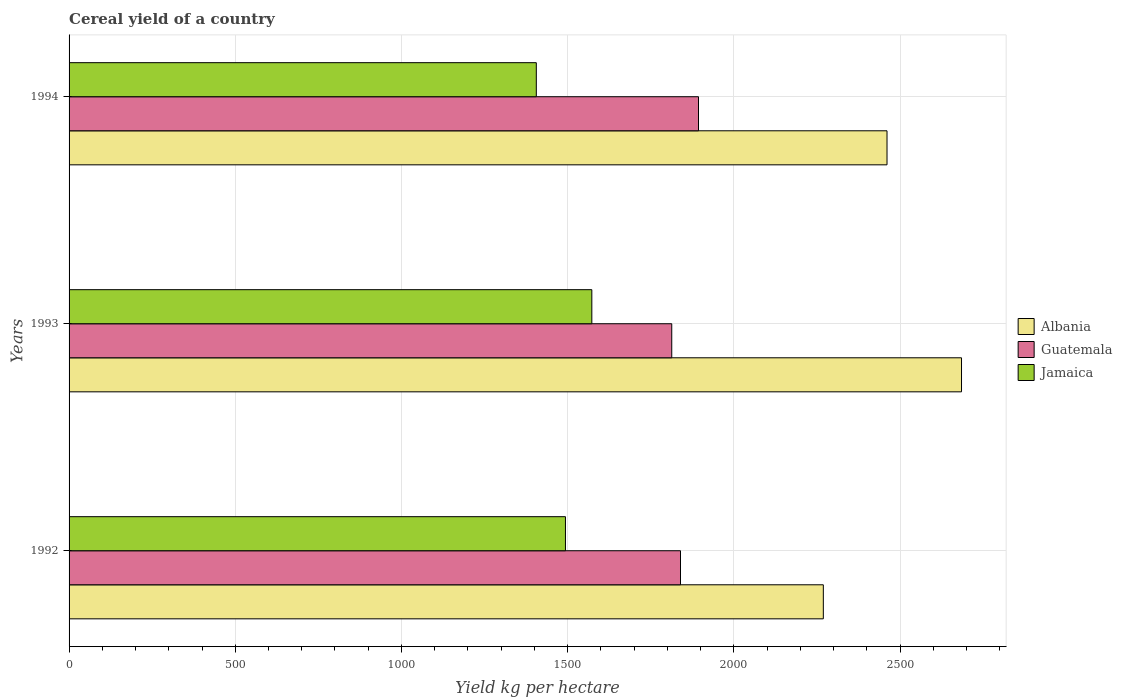Are the number of bars on each tick of the Y-axis equal?
Ensure brevity in your answer.  Yes. How many bars are there on the 2nd tick from the top?
Keep it short and to the point. 3. How many bars are there on the 2nd tick from the bottom?
Your answer should be very brief. 3. In how many cases, is the number of bars for a given year not equal to the number of legend labels?
Your answer should be very brief. 0. What is the total cereal yield in Guatemala in 1994?
Your answer should be compact. 1893.76. Across all years, what is the maximum total cereal yield in Albania?
Provide a succinct answer. 2685.05. Across all years, what is the minimum total cereal yield in Albania?
Offer a terse response. 2269.28. What is the total total cereal yield in Albania in the graph?
Provide a succinct answer. 7415.24. What is the difference between the total cereal yield in Albania in 1992 and that in 1994?
Provide a short and direct response. -191.63. What is the difference between the total cereal yield in Guatemala in 1992 and the total cereal yield in Albania in 1994?
Your answer should be compact. -621.31. What is the average total cereal yield in Jamaica per year?
Provide a succinct answer. 1490.69. In the year 1992, what is the difference between the total cereal yield in Jamaica and total cereal yield in Albania?
Make the answer very short. -775.83. In how many years, is the total cereal yield in Jamaica greater than 2300 kg per hectare?
Ensure brevity in your answer.  0. What is the ratio of the total cereal yield in Guatemala in 1992 to that in 1994?
Ensure brevity in your answer.  0.97. Is the total cereal yield in Albania in 1992 less than that in 1994?
Your answer should be compact. Yes. Is the difference between the total cereal yield in Jamaica in 1993 and 1994 greater than the difference between the total cereal yield in Albania in 1993 and 1994?
Offer a terse response. No. What is the difference between the highest and the second highest total cereal yield in Albania?
Provide a succinct answer. 224.14. What is the difference between the highest and the lowest total cereal yield in Guatemala?
Your response must be concise. 80.48. Is the sum of the total cereal yield in Albania in 1993 and 1994 greater than the maximum total cereal yield in Jamaica across all years?
Make the answer very short. Yes. What does the 1st bar from the top in 1992 represents?
Offer a terse response. Jamaica. What does the 1st bar from the bottom in 1993 represents?
Keep it short and to the point. Albania. Are all the bars in the graph horizontal?
Offer a terse response. Yes. What is the difference between two consecutive major ticks on the X-axis?
Give a very brief answer. 500. Are the values on the major ticks of X-axis written in scientific E-notation?
Provide a short and direct response. No. Does the graph contain any zero values?
Give a very brief answer. No. Where does the legend appear in the graph?
Your response must be concise. Center right. What is the title of the graph?
Make the answer very short. Cereal yield of a country. Does "Iraq" appear as one of the legend labels in the graph?
Give a very brief answer. No. What is the label or title of the X-axis?
Offer a very short reply. Yield kg per hectare. What is the Yield kg per hectare in Albania in 1992?
Offer a terse response. 2269.28. What is the Yield kg per hectare in Guatemala in 1992?
Provide a succinct answer. 1839.6. What is the Yield kg per hectare in Jamaica in 1992?
Your answer should be compact. 1493.45. What is the Yield kg per hectare of Albania in 1993?
Your response must be concise. 2685.05. What is the Yield kg per hectare of Guatemala in 1993?
Offer a terse response. 1813.28. What is the Yield kg per hectare in Jamaica in 1993?
Provide a short and direct response. 1572.82. What is the Yield kg per hectare in Albania in 1994?
Offer a terse response. 2460.91. What is the Yield kg per hectare of Guatemala in 1994?
Ensure brevity in your answer.  1893.76. What is the Yield kg per hectare of Jamaica in 1994?
Your answer should be very brief. 1405.79. Across all years, what is the maximum Yield kg per hectare of Albania?
Keep it short and to the point. 2685.05. Across all years, what is the maximum Yield kg per hectare in Guatemala?
Ensure brevity in your answer.  1893.76. Across all years, what is the maximum Yield kg per hectare of Jamaica?
Your response must be concise. 1572.82. Across all years, what is the minimum Yield kg per hectare of Albania?
Make the answer very short. 2269.28. Across all years, what is the minimum Yield kg per hectare of Guatemala?
Provide a short and direct response. 1813.28. Across all years, what is the minimum Yield kg per hectare of Jamaica?
Your response must be concise. 1405.79. What is the total Yield kg per hectare of Albania in the graph?
Provide a short and direct response. 7415.24. What is the total Yield kg per hectare in Guatemala in the graph?
Your answer should be very brief. 5546.64. What is the total Yield kg per hectare in Jamaica in the graph?
Provide a short and direct response. 4472.06. What is the difference between the Yield kg per hectare of Albania in 1992 and that in 1993?
Your response must be concise. -415.77. What is the difference between the Yield kg per hectare in Guatemala in 1992 and that in 1993?
Keep it short and to the point. 26.32. What is the difference between the Yield kg per hectare in Jamaica in 1992 and that in 1993?
Your answer should be compact. -79.36. What is the difference between the Yield kg per hectare in Albania in 1992 and that in 1994?
Make the answer very short. -191.63. What is the difference between the Yield kg per hectare of Guatemala in 1992 and that in 1994?
Ensure brevity in your answer.  -54.16. What is the difference between the Yield kg per hectare of Jamaica in 1992 and that in 1994?
Give a very brief answer. 87.67. What is the difference between the Yield kg per hectare of Albania in 1993 and that in 1994?
Ensure brevity in your answer.  224.14. What is the difference between the Yield kg per hectare of Guatemala in 1993 and that in 1994?
Provide a short and direct response. -80.48. What is the difference between the Yield kg per hectare in Jamaica in 1993 and that in 1994?
Your answer should be compact. 167.03. What is the difference between the Yield kg per hectare of Albania in 1992 and the Yield kg per hectare of Guatemala in 1993?
Provide a short and direct response. 456. What is the difference between the Yield kg per hectare of Albania in 1992 and the Yield kg per hectare of Jamaica in 1993?
Offer a terse response. 696.47. What is the difference between the Yield kg per hectare in Guatemala in 1992 and the Yield kg per hectare in Jamaica in 1993?
Offer a very short reply. 266.78. What is the difference between the Yield kg per hectare of Albania in 1992 and the Yield kg per hectare of Guatemala in 1994?
Your answer should be compact. 375.52. What is the difference between the Yield kg per hectare of Albania in 1992 and the Yield kg per hectare of Jamaica in 1994?
Offer a very short reply. 863.5. What is the difference between the Yield kg per hectare of Guatemala in 1992 and the Yield kg per hectare of Jamaica in 1994?
Offer a terse response. 433.81. What is the difference between the Yield kg per hectare of Albania in 1993 and the Yield kg per hectare of Guatemala in 1994?
Offer a very short reply. 791.29. What is the difference between the Yield kg per hectare of Albania in 1993 and the Yield kg per hectare of Jamaica in 1994?
Your answer should be compact. 1279.26. What is the difference between the Yield kg per hectare in Guatemala in 1993 and the Yield kg per hectare in Jamaica in 1994?
Make the answer very short. 407.49. What is the average Yield kg per hectare in Albania per year?
Provide a short and direct response. 2471.75. What is the average Yield kg per hectare in Guatemala per year?
Offer a very short reply. 1848.88. What is the average Yield kg per hectare in Jamaica per year?
Your response must be concise. 1490.69. In the year 1992, what is the difference between the Yield kg per hectare in Albania and Yield kg per hectare in Guatemala?
Offer a terse response. 429.68. In the year 1992, what is the difference between the Yield kg per hectare in Albania and Yield kg per hectare in Jamaica?
Make the answer very short. 775.83. In the year 1992, what is the difference between the Yield kg per hectare of Guatemala and Yield kg per hectare of Jamaica?
Offer a terse response. 346.15. In the year 1993, what is the difference between the Yield kg per hectare of Albania and Yield kg per hectare of Guatemala?
Your response must be concise. 871.77. In the year 1993, what is the difference between the Yield kg per hectare in Albania and Yield kg per hectare in Jamaica?
Your answer should be very brief. 1112.23. In the year 1993, what is the difference between the Yield kg per hectare of Guatemala and Yield kg per hectare of Jamaica?
Provide a succinct answer. 240.46. In the year 1994, what is the difference between the Yield kg per hectare of Albania and Yield kg per hectare of Guatemala?
Ensure brevity in your answer.  567.15. In the year 1994, what is the difference between the Yield kg per hectare in Albania and Yield kg per hectare in Jamaica?
Your answer should be very brief. 1055.12. In the year 1994, what is the difference between the Yield kg per hectare in Guatemala and Yield kg per hectare in Jamaica?
Keep it short and to the point. 487.97. What is the ratio of the Yield kg per hectare of Albania in 1992 to that in 1993?
Keep it short and to the point. 0.85. What is the ratio of the Yield kg per hectare in Guatemala in 1992 to that in 1993?
Offer a very short reply. 1.01. What is the ratio of the Yield kg per hectare of Jamaica in 1992 to that in 1993?
Offer a terse response. 0.95. What is the ratio of the Yield kg per hectare of Albania in 1992 to that in 1994?
Make the answer very short. 0.92. What is the ratio of the Yield kg per hectare in Guatemala in 1992 to that in 1994?
Ensure brevity in your answer.  0.97. What is the ratio of the Yield kg per hectare of Jamaica in 1992 to that in 1994?
Offer a very short reply. 1.06. What is the ratio of the Yield kg per hectare of Albania in 1993 to that in 1994?
Ensure brevity in your answer.  1.09. What is the ratio of the Yield kg per hectare in Guatemala in 1993 to that in 1994?
Make the answer very short. 0.96. What is the ratio of the Yield kg per hectare in Jamaica in 1993 to that in 1994?
Provide a succinct answer. 1.12. What is the difference between the highest and the second highest Yield kg per hectare of Albania?
Provide a succinct answer. 224.14. What is the difference between the highest and the second highest Yield kg per hectare in Guatemala?
Provide a succinct answer. 54.16. What is the difference between the highest and the second highest Yield kg per hectare of Jamaica?
Make the answer very short. 79.36. What is the difference between the highest and the lowest Yield kg per hectare of Albania?
Offer a terse response. 415.77. What is the difference between the highest and the lowest Yield kg per hectare in Guatemala?
Ensure brevity in your answer.  80.48. What is the difference between the highest and the lowest Yield kg per hectare of Jamaica?
Provide a succinct answer. 167.03. 